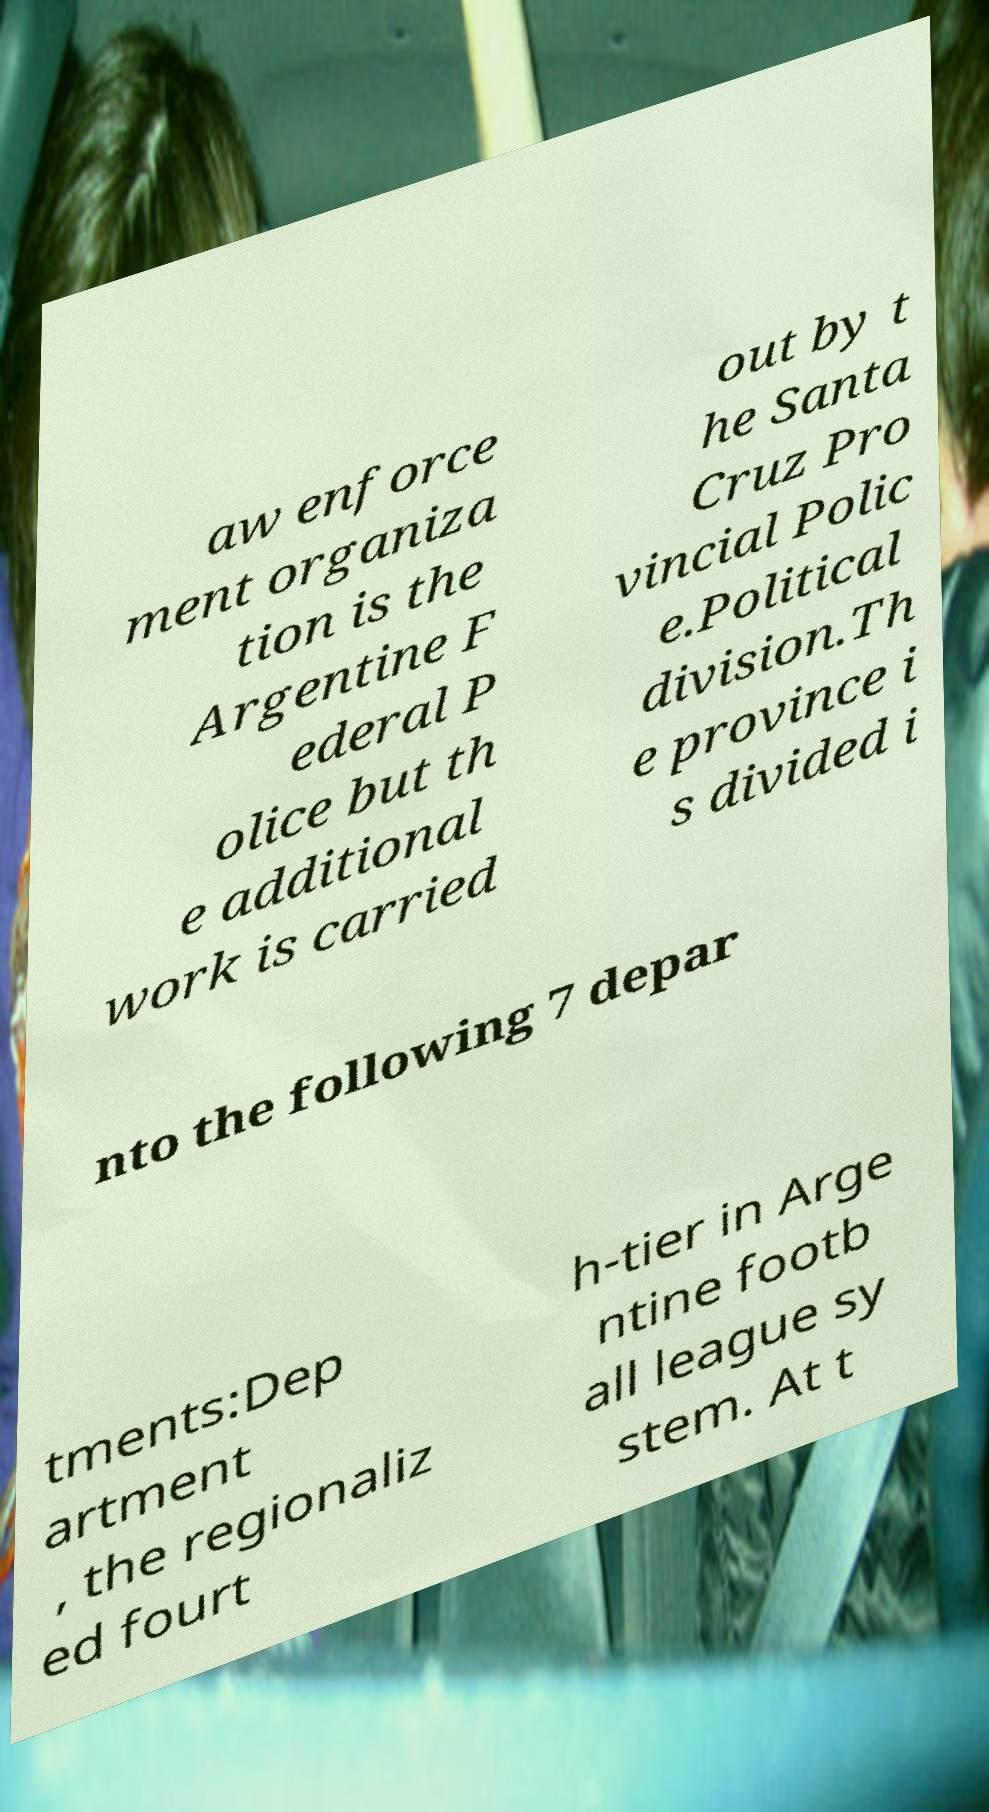Could you assist in decoding the text presented in this image and type it out clearly? aw enforce ment organiza tion is the Argentine F ederal P olice but th e additional work is carried out by t he Santa Cruz Pro vincial Polic e.Political division.Th e province i s divided i nto the following 7 depar tments:Dep artment , the regionaliz ed fourt h-tier in Arge ntine footb all league sy stem. At t 